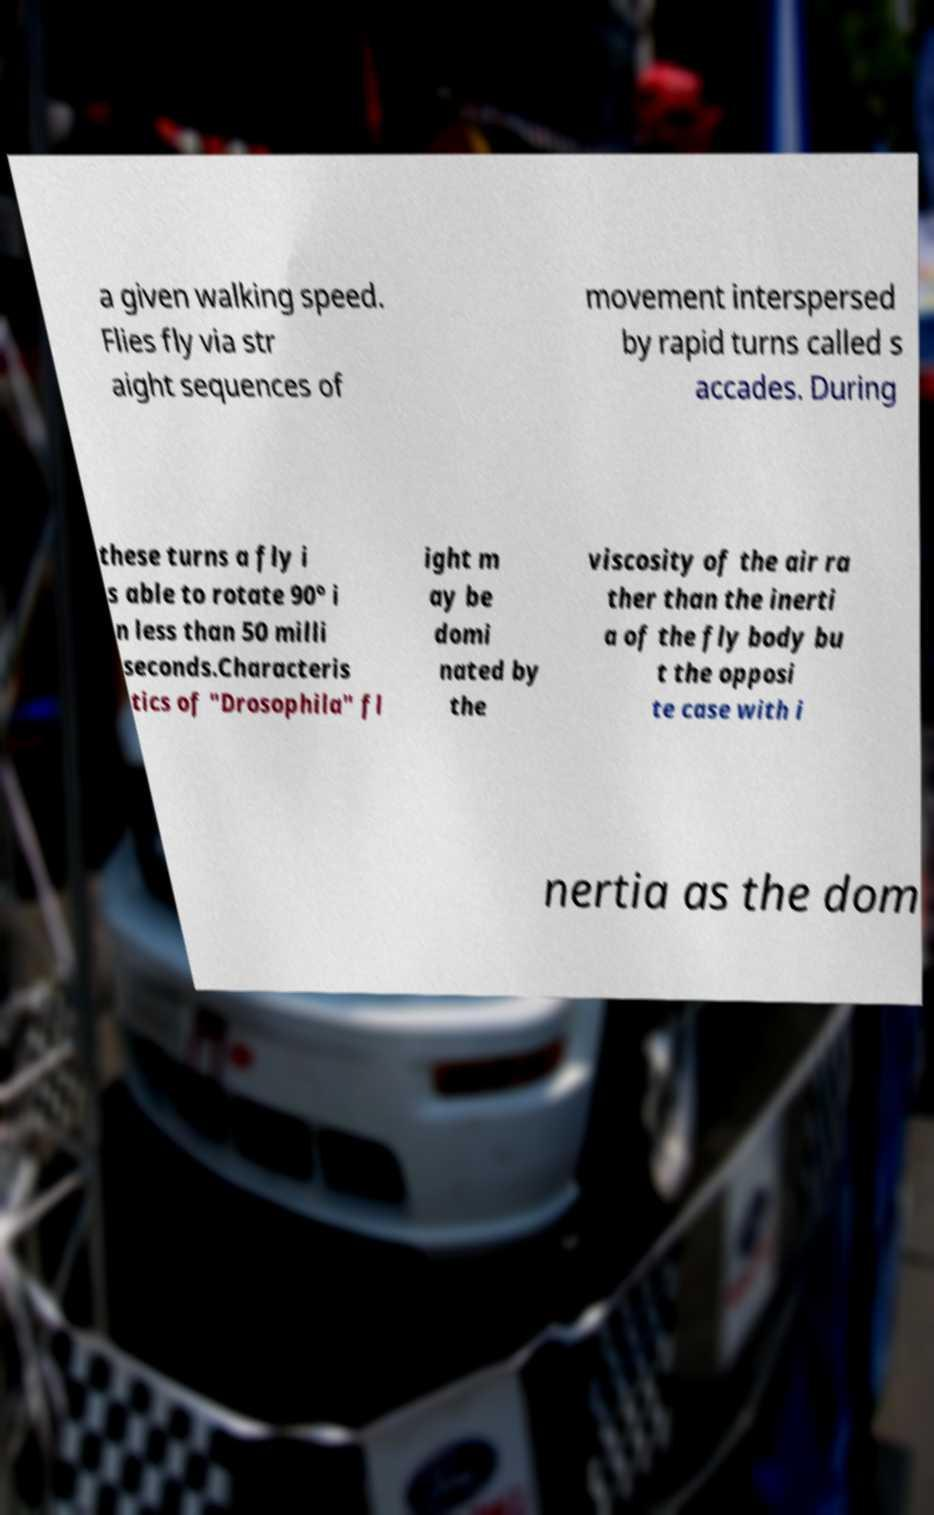What messages or text are displayed in this image? I need them in a readable, typed format. a given walking speed. Flies fly via str aight sequences of movement interspersed by rapid turns called s accades. During these turns a fly i s able to rotate 90° i n less than 50 milli seconds.Characteris tics of "Drosophila" fl ight m ay be domi nated by the viscosity of the air ra ther than the inerti a of the fly body bu t the opposi te case with i nertia as the dom 